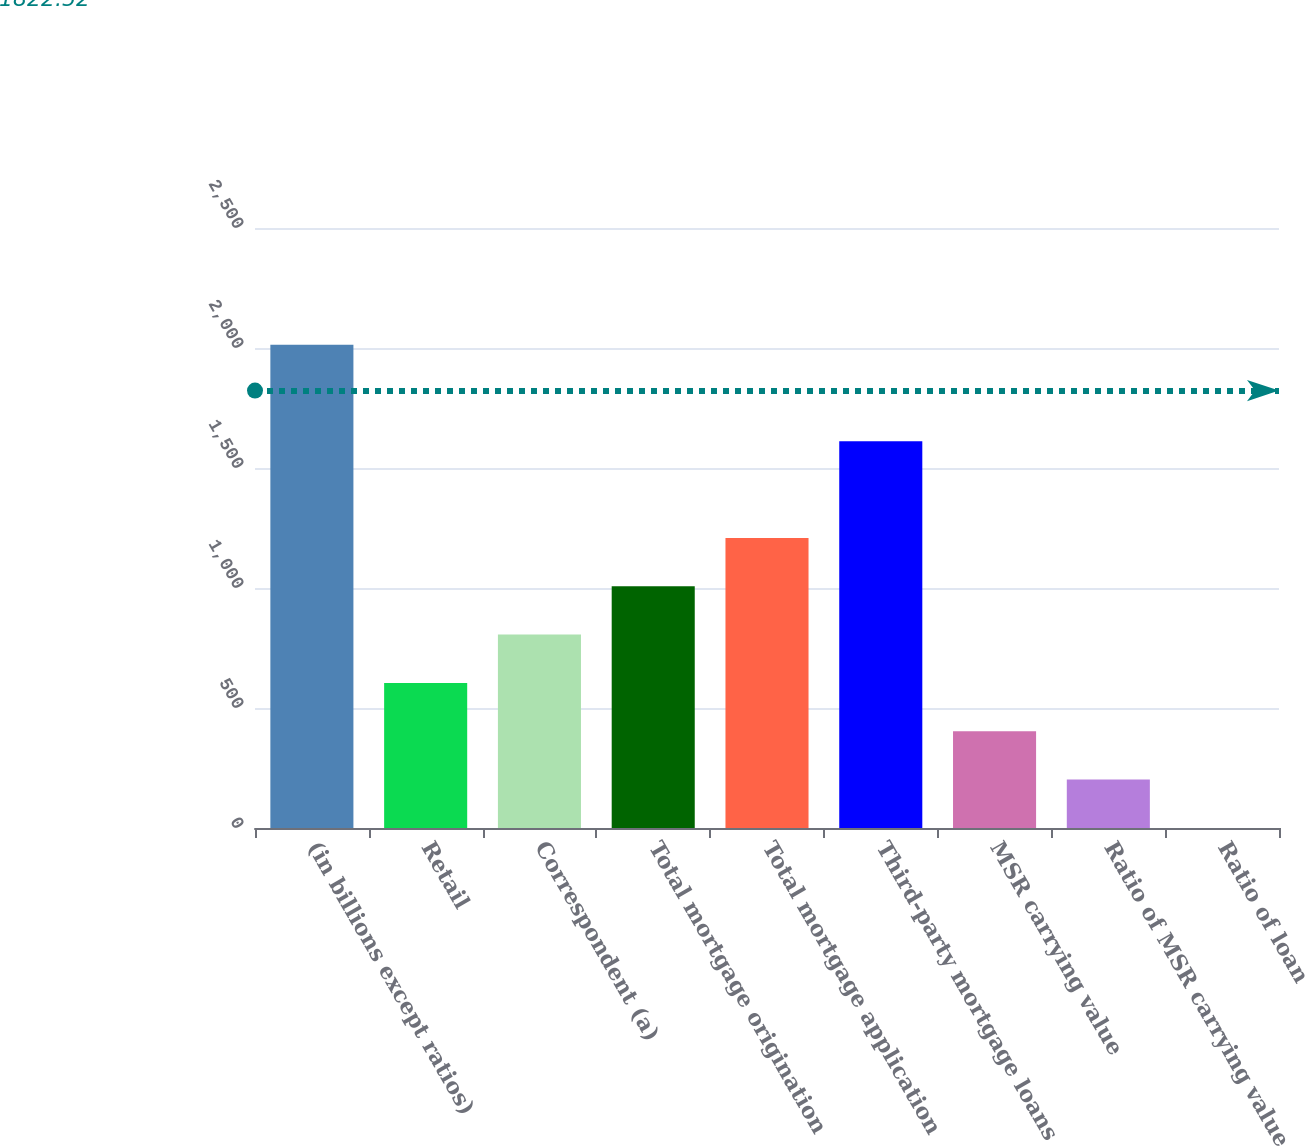<chart> <loc_0><loc_0><loc_500><loc_500><bar_chart><fcel>(in billions except ratios)<fcel>Retail<fcel>Correspondent (a)<fcel>Total mortgage origination<fcel>Total mortgage application<fcel>Third-party mortgage loans<fcel>MSR carrying value<fcel>Ratio of MSR carrying value<fcel>Ratio of loan<nl><fcel>2014<fcel>604.44<fcel>805.8<fcel>1007.16<fcel>1208.52<fcel>1611.24<fcel>403.08<fcel>201.72<fcel>0.36<nl></chart> 